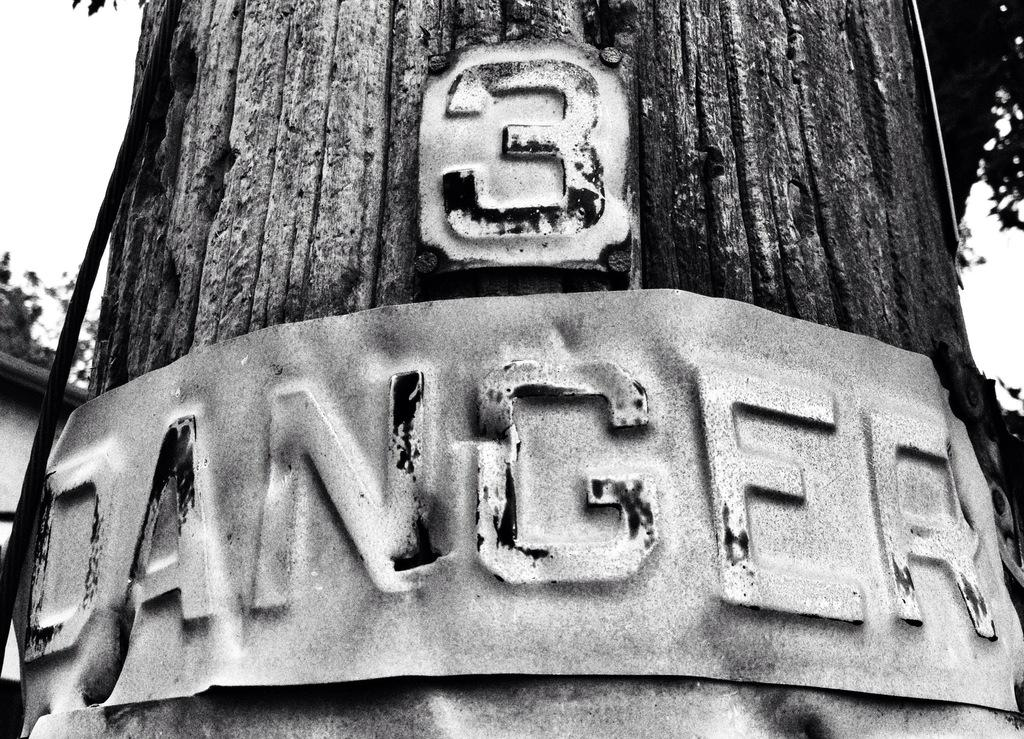What is the main subject of the image? The main subject of the image is an old photograph of a tree trunk. Is there anything attached to the tree trunk in the image? Yes, there is an iron plate attached to the tree trunk. What is written on the iron plate? The word "dangerous" is written on the iron plate. How many nets are visible in the image? There are no nets present in the image. What type of hate is being expressed in the image? There is no hate expressed in the image; it only features a tree trunk with an iron plate. 